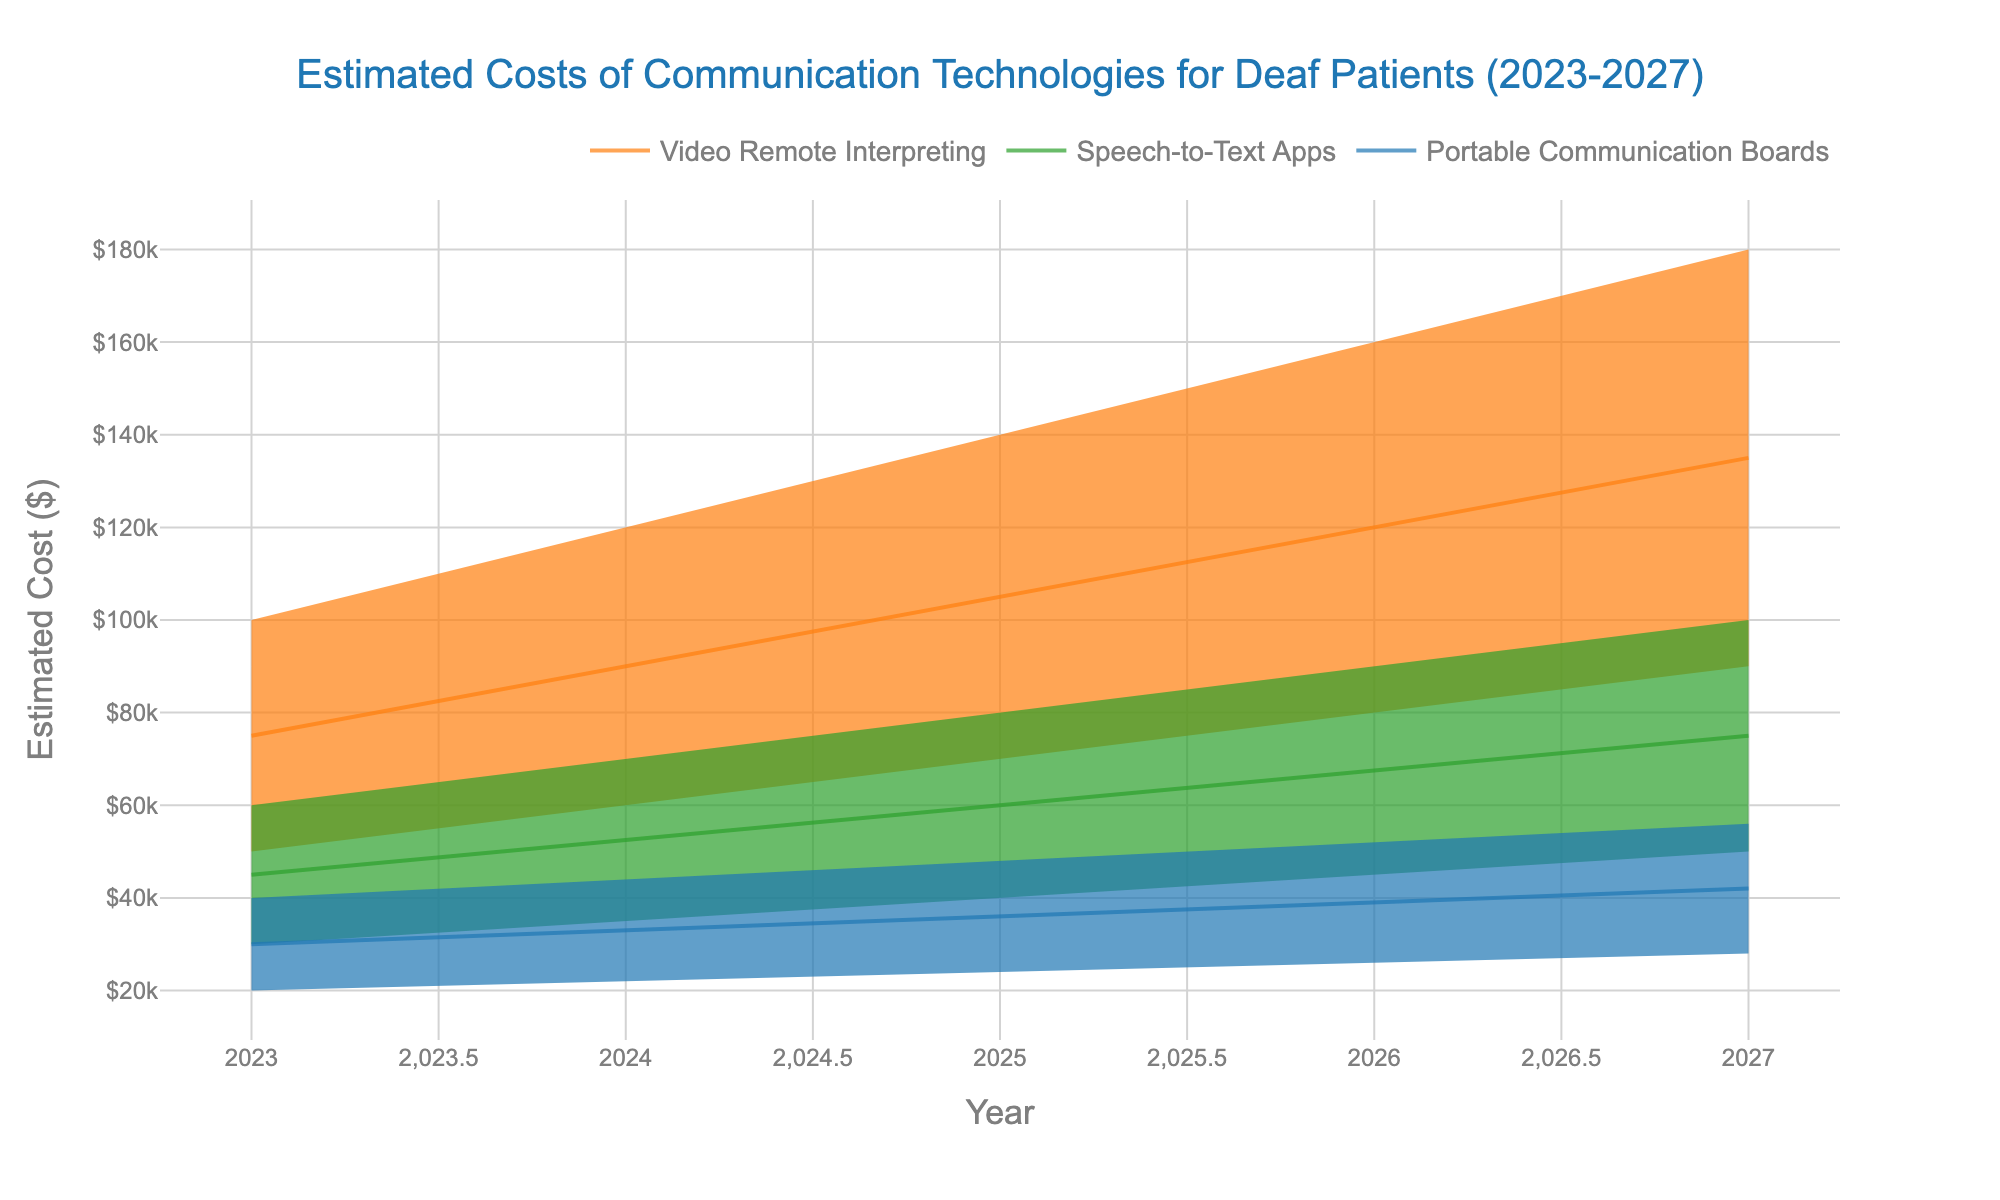What is the title of the chart? The title is located at the top center of the chart, typically summarizing the main topic of the figure.
Answer: Estimated Costs of Communication Technologies for Deaf Patients (2023-2027) Which technology is projected to have the highest cost by 2027 under high adoption? Look for the data points corresponding to 2027 and the technology labels. The highest value on the y-axis under high adoption will indicate the answer.
Answer: Video Remote Interpreting How much is the cost difference between Speech-to-Text Apps and Portable Communication Boards in 2025 under medium adoption? Identify the medium adoption costs for both technologies in 2025, then subtract the cost of Portable Communication Boards from Speech-to-Text Apps.
Answer: $24,000 Which technology shows the least increase in costs from 2023 to 2027 under low adoption? Calculate the cost difference from 2023 to 2027 for all technologies under low adoption, and find the smallest increase.
Answer: Portable Communication Boards What is the medium adoption cost for Video Remote Interpreting in 2024? Check the corresponding data point for Video Remote Interpreting in 2024 under medium adoption.
Answer: $90,000 Compare the rate of cost increase per year for Speech-to-Text Apps and Portable Communication Boards under medium adoption. Which one is higher? Find the yearly increase in cost for both technologies under medium adoption, compare them by calculating the differences year over year and summing them up to find the average annual increase.
Answer: Speech-to-Text Apps Is the cost of Video Remote Interpreting in 2025 within the range of costs for Speech-to-Text Apps in 2027? Identify the cost range (low to high adoption) for Speech-to-Text Apps in 2027 and check if the 2025 cost for Video Remote Interpreting falls within this range.
Answer: No What is the expected cost of Portable Communication Boards in 2026 under high adoption? Locate the high adoption data point for Portable Communication Boards in 2026.
Answer: $52,000 Which year and technology have the closest costs between medium and low adoption? Calculate the differences between medium and low adoption costs for each year and technology, and find the smallest difference.
Answer: Portable Communication Boards in 2023 What is the total projected cost increase from 2023 to 2027 for Video Remote Interpreting under high adoption? Subtract the 2023 high adoption cost from the 2027 high adoption cost for Video Remote Interpreting.
Answer: $80,000 